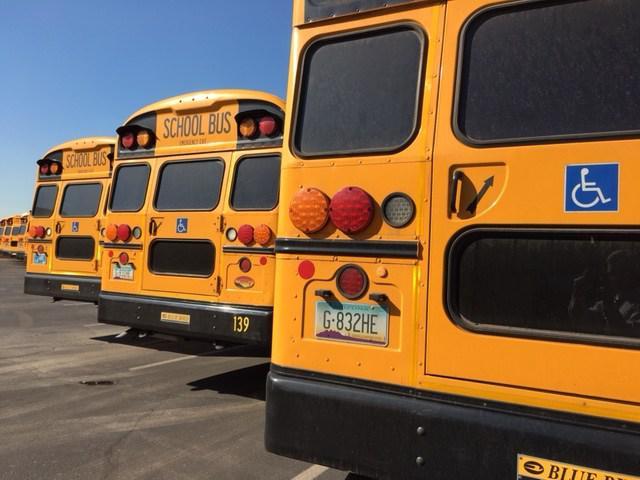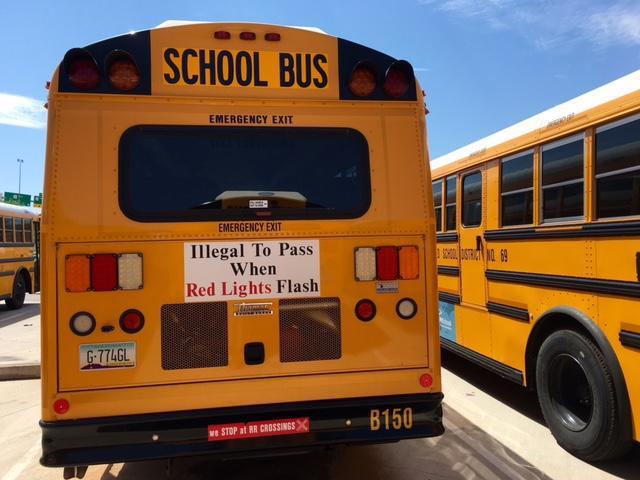The first image is the image on the left, the second image is the image on the right. Considering the images on both sides, is "In the image to the left, there are less than six buses." valid? Answer yes or no. Yes. The first image is the image on the left, the second image is the image on the right. For the images shown, is this caption "At least one image shows the rear-facing tail end of a parked yellow bus, and no image shows a non-flat bus front." true? Answer yes or no. Yes. 